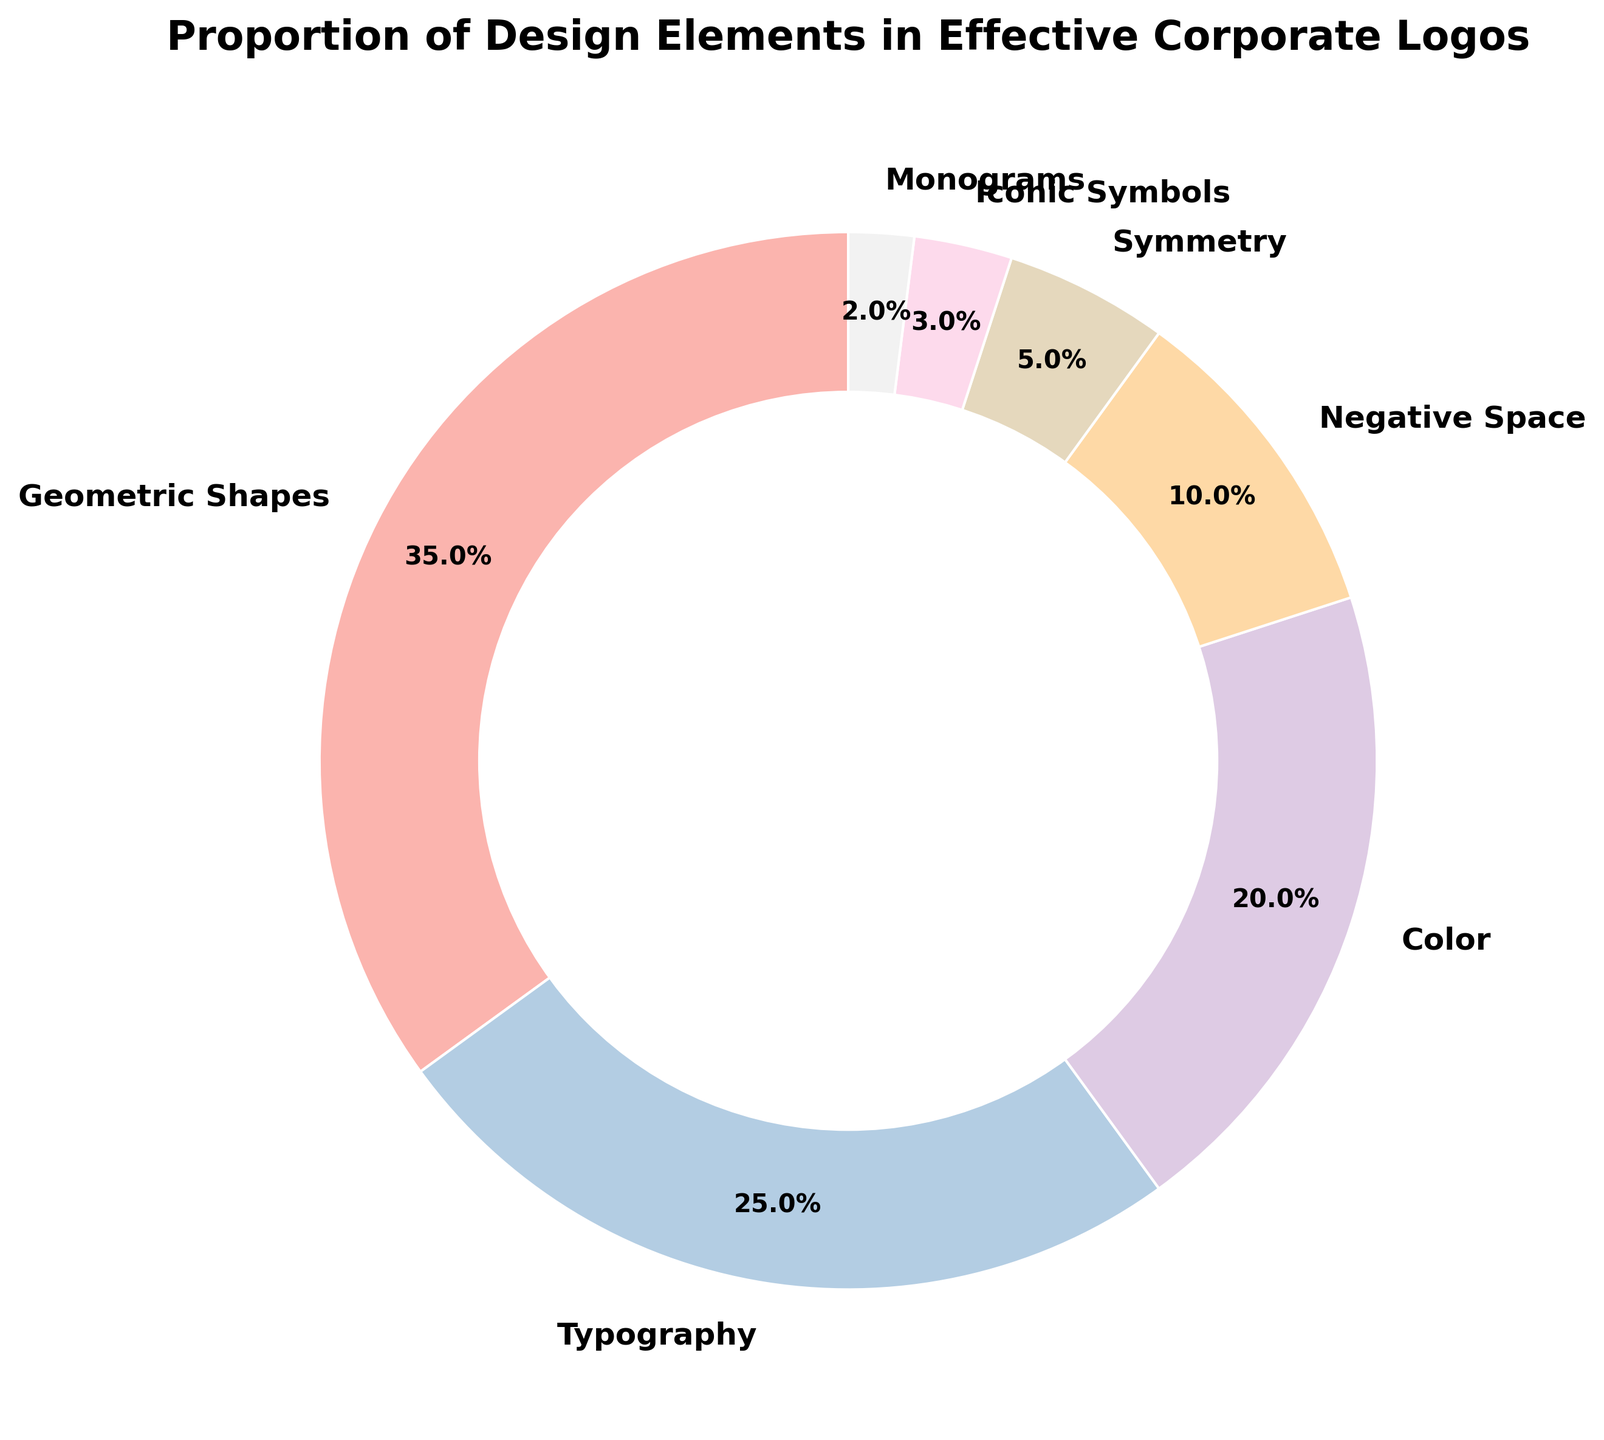What's the element with the highest proportion in effective corporate logos? The segment of the pie chart labeled "Geometric Shapes" occupies the largest area in the chart, indicating it has the highest proportion.
Answer: Geometric Shapes What percentage of corporate logos are effectively designed using typography and color combined? Combine the percentages of Typography (25%) and Color (20%) from the pie chart. 25% + 20% = 45%.
Answer: 45% Which design element has a smaller proportion: Symmetry or Negative Space? Compare the areas labeled "Symmetry" and "Negative Space" in the pie chart. Symmetry has 5% and Negative Space has 10%. Since 5% < 10%, Symmetry has a smaller proportion.
Answer: Symmetry By how much does the proportion of Geometric Shapes exceed the proportion of Iconic Symbols? Subtract the percentage of Iconic Symbols (3%) from the Geometric Shapes (35%) using the pie chart data. 35% - 3% = 32%.
Answer: 32% What is the combined proportion of the least common design elements in effective corporate logos? Sum the percentages of the least common elements: Iconic Symbols (3%) and Monograms (2%) from the pie chart. 3% + 2% = 5%.
Answer: 5% If we only consider Typography, Color, and Negative Space, what is their average proportion in corporate logos? Calculate the average by summing the percentages for Typography (25%), Color (20%), and Negative Space (10%) and then dividing by 3. (25% + 20% + 10%) / 3 = 55% / 3 ≈ 18.33%.
Answer: 18.33% Are there more corporate logos designed using Monograms or Symmetry? Compare the percentages for Monograms (2%) and Symmetry (5%) from the pie chart. Since 2% < 5%, more logos are designed using Symmetry.
Answer: Symmetry Which color is used to represent the largest segment in the pie chart? The largest segment labeled "Geometric Shapes" is visually coded in the color palette provided. As the design uses a pastel color palette, observe the specific hue used in that segment.
Answer: The specific pastel color for the largest segment. (Exact color description may vary based on reader's perception) What is the proportion difference between the use of Negative Space and Typography? Subtract the percentage of Negative Space (10%) from Typography (25%) from the pie chart. 25% - 10% = 15%.
Answer: 15% How much more common is the use of Color compared to Monograms in corporate logos? Subtract the percentage of Monograms (2%) from Color (20%) from the pie chart. 20% - 2% = 18%.
Answer: 18% 